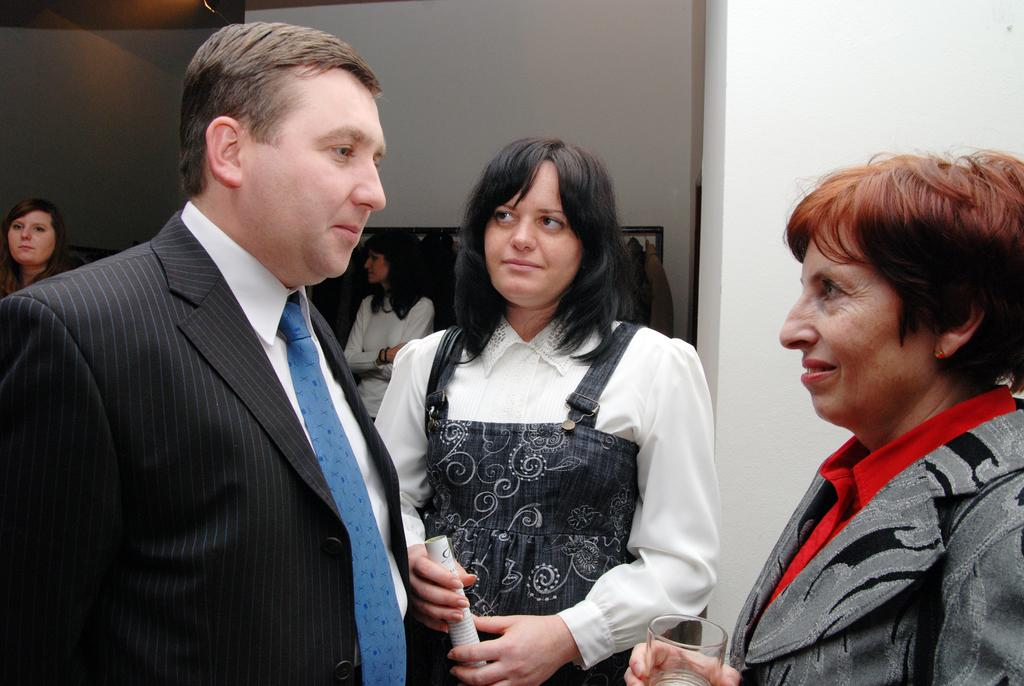How many people are present in the image? There are three persons in the image. What is one of the persons holding? One of the persons is holding a paper and a glass. Can you describe the background of the image? There are other people and a wall in the background of the image. What type of bear can be seen in the image? There is no bear present in the image. What teeth can be seen in the image? There are no teeth visible in the image. 